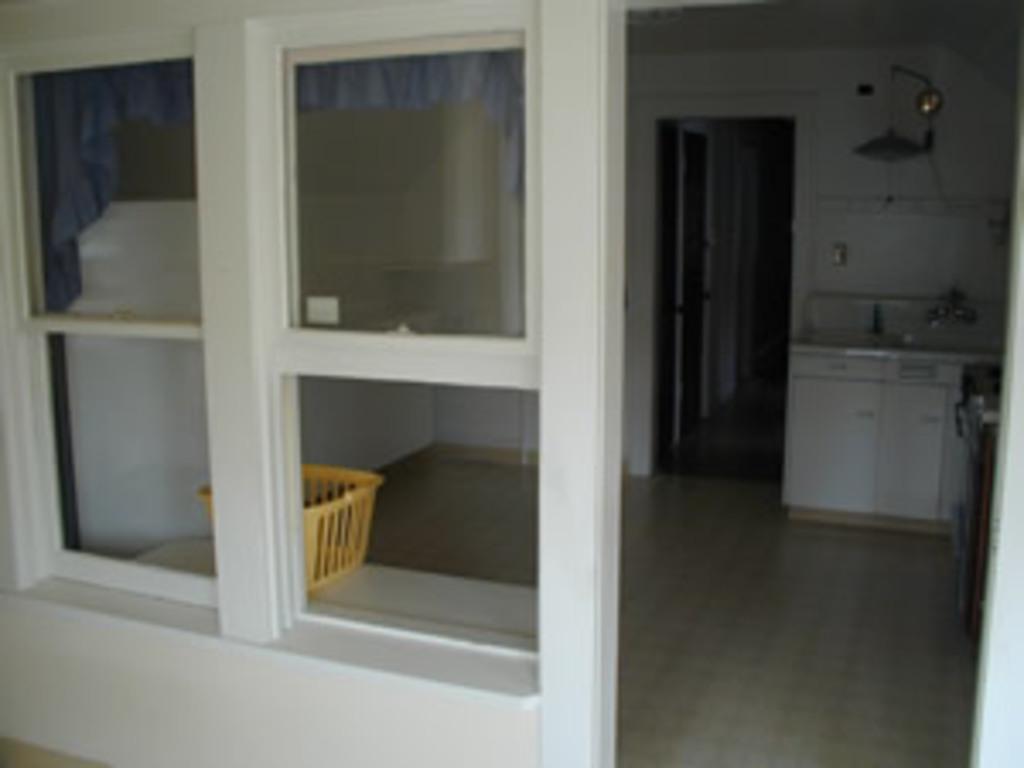Describe this image in one or two sentences. In the image there is a door with glass windows. Behind the windows there is a table with basket. On the right side of the image there is a stove and also there is a sink and cupboards. Beside that there is a room with door. 